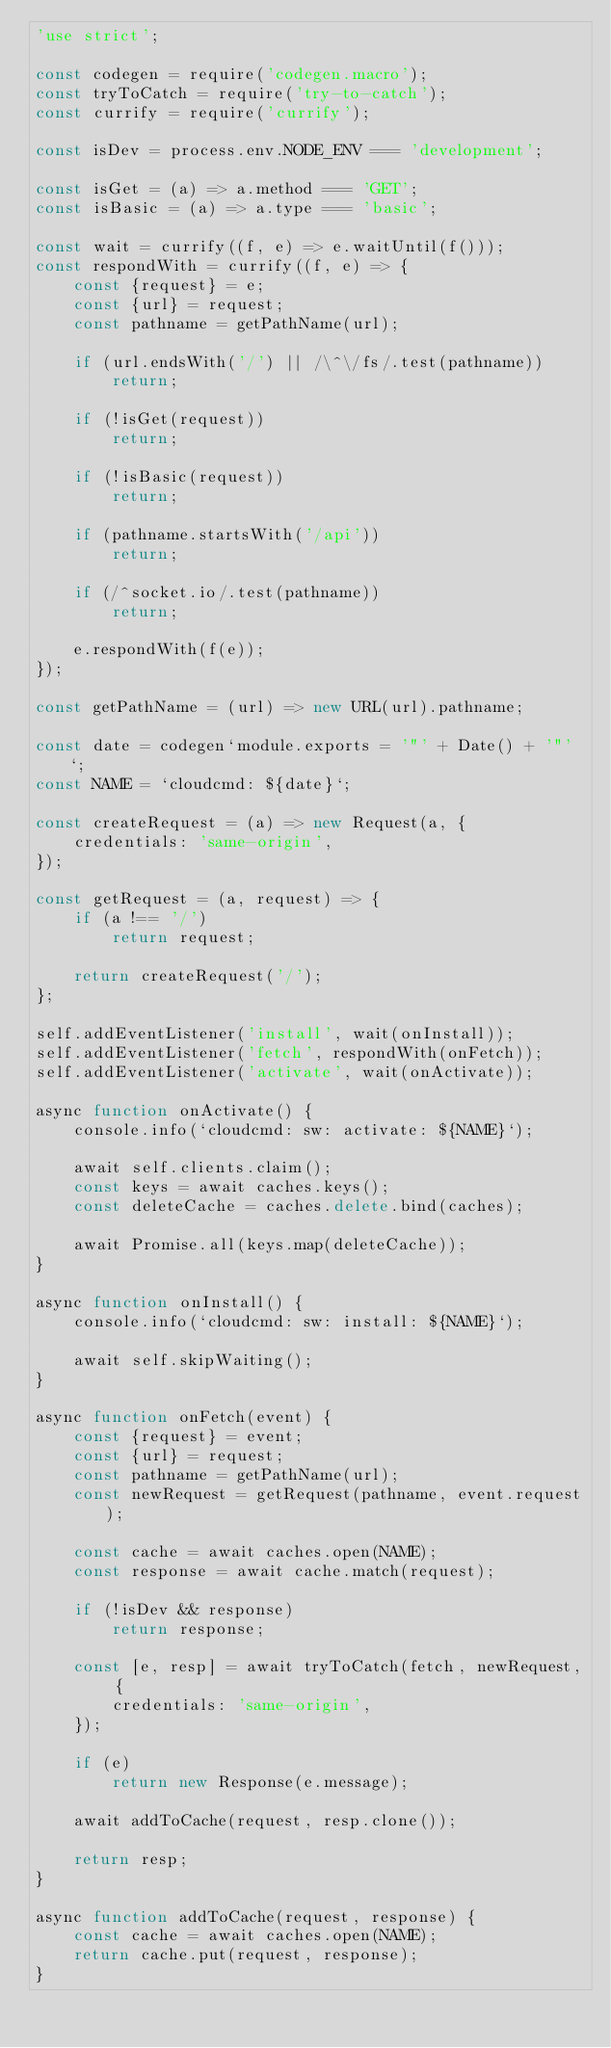<code> <loc_0><loc_0><loc_500><loc_500><_JavaScript_>'use strict';

const codegen = require('codegen.macro');
const tryToCatch = require('try-to-catch');
const currify = require('currify');

const isDev = process.env.NODE_ENV === 'development';

const isGet = (a) => a.method === 'GET';
const isBasic = (a) => a.type === 'basic';

const wait = currify((f, e) => e.waitUntil(f()));
const respondWith = currify((f, e) => {
    const {request} = e;
    const {url} = request;
    const pathname = getPathName(url);
    
    if (url.endsWith('/') || /\^\/fs/.test(pathname))
        return;
    
    if (!isGet(request))
        return;
    
    if (!isBasic(request))
        return;
    
    if (pathname.startsWith('/api'))
        return;
    
    if (/^socket.io/.test(pathname))
        return;
    
    e.respondWith(f(e));
});

const getPathName = (url) => new URL(url).pathname;

const date = codegen`module.exports = '"' + Date() + '"'`;
const NAME = `cloudcmd: ${date}`;

const createRequest = (a) => new Request(a, {
    credentials: 'same-origin',
});

const getRequest = (a, request) => {
    if (a !== '/')
        return request;
    
    return createRequest('/');
};

self.addEventListener('install', wait(onInstall));
self.addEventListener('fetch', respondWith(onFetch));
self.addEventListener('activate', wait(onActivate));

async function onActivate() {
    console.info(`cloudcmd: sw: activate: ${NAME}`);
    
    await self.clients.claim();
    const keys = await caches.keys();
    const deleteCache = caches.delete.bind(caches);
    
    await Promise.all(keys.map(deleteCache));
}

async function onInstall() {
    console.info(`cloudcmd: sw: install: ${NAME}`);
    
    await self.skipWaiting();
}

async function onFetch(event) {
    const {request} = event;
    const {url} = request;
    const pathname = getPathName(url);
    const newRequest = getRequest(pathname, event.request);
    
    const cache = await caches.open(NAME);
    const response = await cache.match(request);
    
    if (!isDev && response)
        return response;
    
    const [e, resp] = await tryToCatch(fetch, newRequest, {
        credentials: 'same-origin',
    });
    
    if (e)
        return new Response(e.message);
    
    await addToCache(request, resp.clone());
    
    return resp;
}

async function addToCache(request, response) {
    const cache = await caches.open(NAME);
    return cache.put(request, response);
}

</code> 